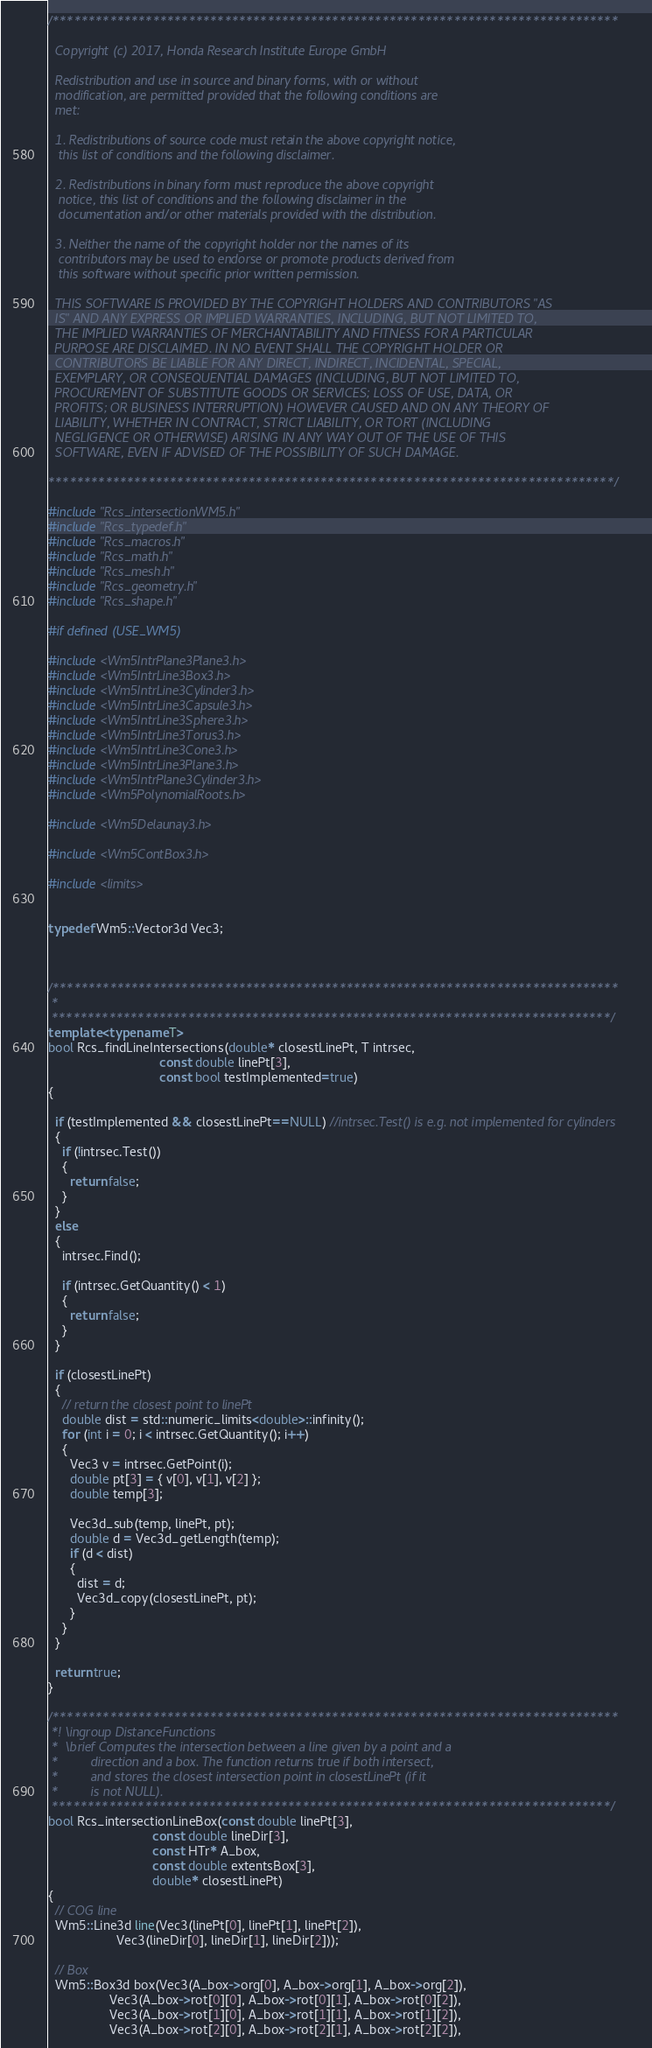Convert code to text. <code><loc_0><loc_0><loc_500><loc_500><_C++_>/*******************************************************************************

  Copyright (c) 2017, Honda Research Institute Europe GmbH

  Redistribution and use in source and binary forms, with or without
  modification, are permitted provided that the following conditions are
  met:

  1. Redistributions of source code must retain the above copyright notice,
   this list of conditions and the following disclaimer.

  2. Redistributions in binary form must reproduce the above copyright
   notice, this list of conditions and the following disclaimer in the
   documentation and/or other materials provided with the distribution.

  3. Neither the name of the copyright holder nor the names of its
   contributors may be used to endorse or promote products derived from
   this software without specific prior written permission.

  THIS SOFTWARE IS PROVIDED BY THE COPYRIGHT HOLDERS AND CONTRIBUTORS "AS
  IS" AND ANY EXPRESS OR IMPLIED WARRANTIES, INCLUDING, BUT NOT LIMITED TO,
  THE IMPLIED WARRANTIES OF MERCHANTABILITY AND FITNESS FOR A PARTICULAR
  PURPOSE ARE DISCLAIMED. IN NO EVENT SHALL THE COPYRIGHT HOLDER OR
  CONTRIBUTORS BE LIABLE FOR ANY DIRECT, INDIRECT, INCIDENTAL, SPECIAL,
  EXEMPLARY, OR CONSEQUENTIAL DAMAGES (INCLUDING, BUT NOT LIMITED TO,
  PROCUREMENT OF SUBSTITUTE GOODS OR SERVICES; LOSS OF USE, DATA, OR
  PROFITS; OR BUSINESS INTERRUPTION) HOWEVER CAUSED AND ON ANY THEORY OF
  LIABILITY, WHETHER IN CONTRACT, STRICT LIABILITY, OR TORT (INCLUDING
  NEGLIGENCE OR OTHERWISE) ARISING IN ANY WAY OUT OF THE USE OF THIS
  SOFTWARE, EVEN IF ADVISED OF THE POSSIBILITY OF SUCH DAMAGE.

*******************************************************************************/

#include "Rcs_intersectionWM5.h"
#include "Rcs_typedef.h"
#include "Rcs_macros.h"
#include "Rcs_math.h"
#include "Rcs_mesh.h"
#include "Rcs_geometry.h"
#include "Rcs_shape.h"

#if defined (USE_WM5)

#include <Wm5IntrPlane3Plane3.h>
#include <Wm5IntrLine3Box3.h>
#include <Wm5IntrLine3Cylinder3.h>
#include <Wm5IntrLine3Capsule3.h>
#include <Wm5IntrLine3Sphere3.h>
#include <Wm5IntrLine3Torus3.h>
#include <Wm5IntrLine3Cone3.h>
#include <Wm5IntrLine3Plane3.h>
#include <Wm5IntrPlane3Cylinder3.h>
#include <Wm5PolynomialRoots.h>

#include <Wm5Delaunay3.h>

#include <Wm5ContBox3.h>

#include <limits>


typedef Wm5::Vector3d Vec3;



/*******************************************************************************
 *
 ******************************************************************************/
template <typename T>
bool Rcs_findLineIntersections(double* closestLinePt, T intrsec,
                               const double linePt[3],
                               const bool testImplemented=true)
{

  if (testImplemented && closestLinePt==NULL) //intrsec.Test() is e.g. not implemented for cylinders
  {
    if (!intrsec.Test())
    {
      return false;
    }
  }
  else
  {
    intrsec.Find();

    if (intrsec.GetQuantity() < 1)
    {
      return false;
    }
  }

  if (closestLinePt)
  {
    // return the closest point to linePt
    double dist = std::numeric_limits<double>::infinity();
    for (int i = 0; i < intrsec.GetQuantity(); i++)
    {
      Vec3 v = intrsec.GetPoint(i);
      double pt[3] = { v[0], v[1], v[2] };
      double temp[3];

      Vec3d_sub(temp, linePt, pt);
      double d = Vec3d_getLength(temp);
      if (d < dist)
      {
        dist = d;
        Vec3d_copy(closestLinePt, pt);
      }
    }
  }

  return true;
}

/*******************************************************************************
 *! \ingroup DistanceFunctions
 *  \brief Computes the intersection between a line given by a point and a
 *         direction and a box. The function returns true if both intersect,
 *         and stores the closest intersection point in closestLinePt (if it
 *         is not NULL).
 ******************************************************************************/
bool Rcs_intersectionLineBox(const double linePt[3],
                             const double lineDir[3],
                             const HTr* A_box,
                             const double extentsBox[3],
                             double* closestLinePt)
{
  // COG line
  Wm5::Line3d line(Vec3(linePt[0], linePt[1], linePt[2]),
                   Vec3(lineDir[0], lineDir[1], lineDir[2]));

  // Box
  Wm5::Box3d box(Vec3(A_box->org[0], A_box->org[1], A_box->org[2]),
                 Vec3(A_box->rot[0][0], A_box->rot[0][1], A_box->rot[0][2]),
                 Vec3(A_box->rot[1][0], A_box->rot[1][1], A_box->rot[1][2]),
                 Vec3(A_box->rot[2][0], A_box->rot[2][1], A_box->rot[2][2]),</code> 